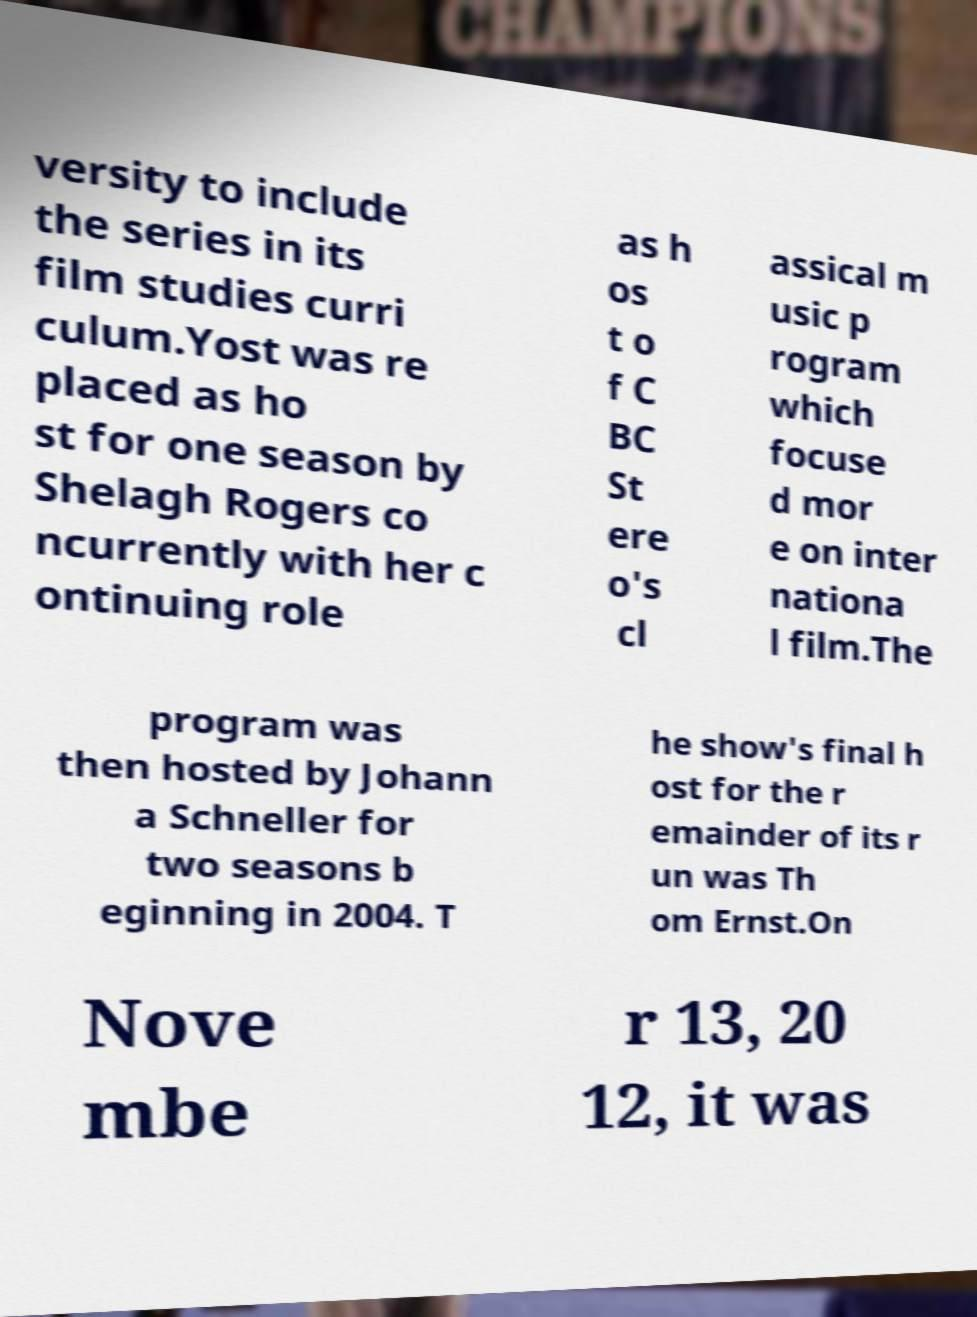Could you assist in decoding the text presented in this image and type it out clearly? versity to include the series in its film studies curri culum.Yost was re placed as ho st for one season by Shelagh Rogers co ncurrently with her c ontinuing role as h os t o f C BC St ere o's cl assical m usic p rogram which focuse d mor e on inter nationa l film.The program was then hosted by Johann a Schneller for two seasons b eginning in 2004. T he show's final h ost for the r emainder of its r un was Th om Ernst.On Nove mbe r 13, 20 12, it was 